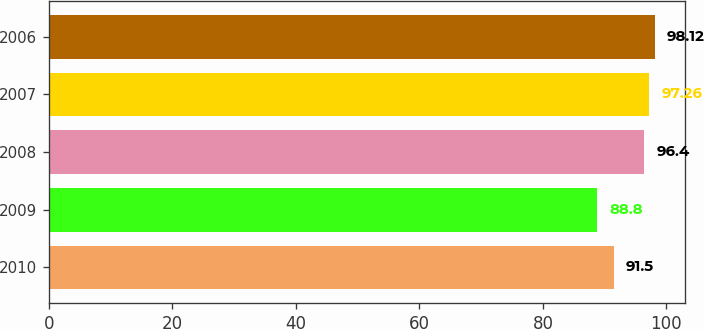Convert chart to OTSL. <chart><loc_0><loc_0><loc_500><loc_500><bar_chart><fcel>2010<fcel>2009<fcel>2008<fcel>2007<fcel>2006<nl><fcel>91.5<fcel>88.8<fcel>96.4<fcel>97.26<fcel>98.12<nl></chart> 